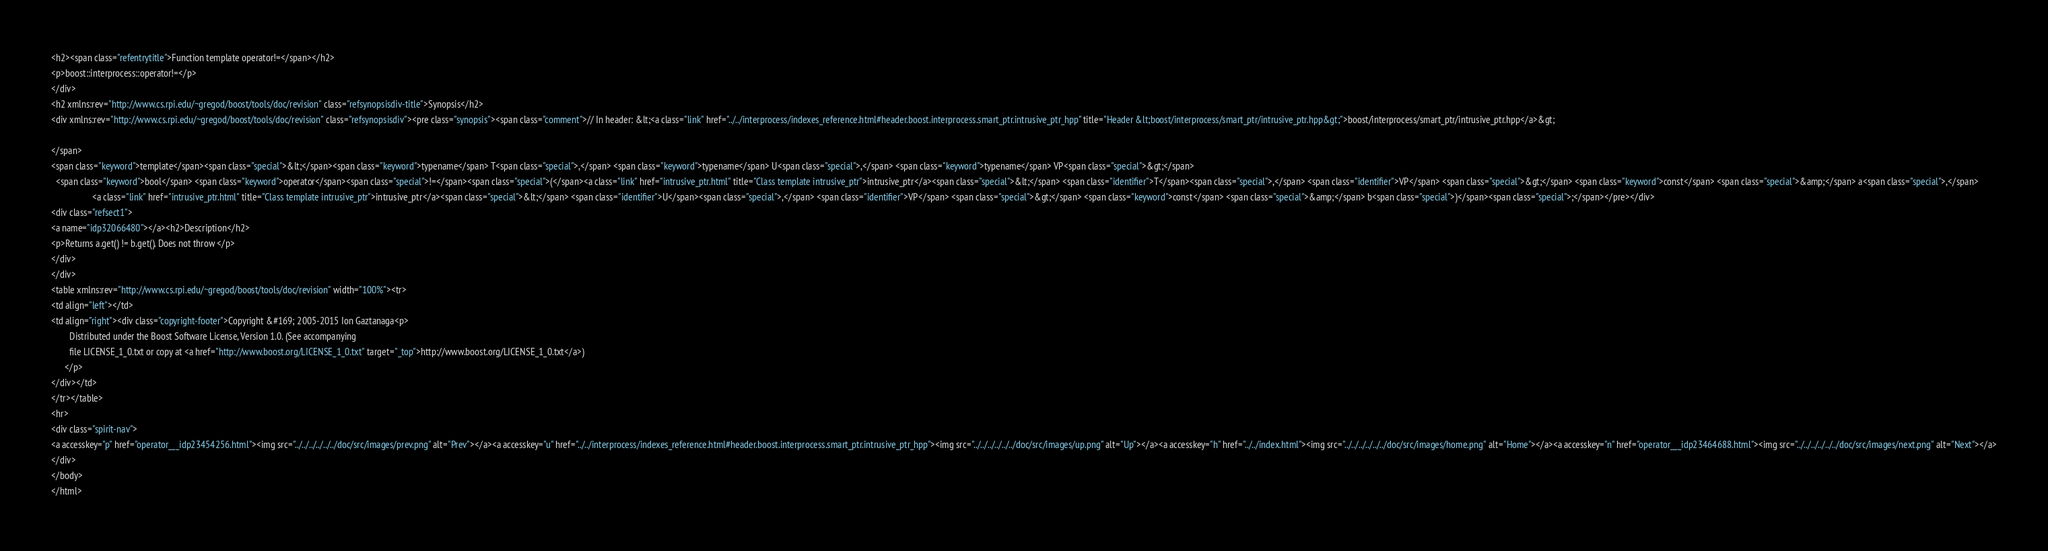Convert code to text. <code><loc_0><loc_0><loc_500><loc_500><_HTML_><h2><span class="refentrytitle">Function template operator!=</span></h2>
<p>boost::interprocess::operator!=</p>
</div>
<h2 xmlns:rev="http://www.cs.rpi.edu/~gregod/boost/tools/doc/revision" class="refsynopsisdiv-title">Synopsis</h2>
<div xmlns:rev="http://www.cs.rpi.edu/~gregod/boost/tools/doc/revision" class="refsynopsisdiv"><pre class="synopsis"><span class="comment">// In header: &lt;<a class="link" href="../../interprocess/indexes_reference.html#header.boost.interprocess.smart_ptr.intrusive_ptr_hpp" title="Header &lt;boost/interprocess/smart_ptr/intrusive_ptr.hpp&gt;">boost/interprocess/smart_ptr/intrusive_ptr.hpp</a>&gt;

</span>
<span class="keyword">template</span><span class="special">&lt;</span><span class="keyword">typename</span> T<span class="special">,</span> <span class="keyword">typename</span> U<span class="special">,</span> <span class="keyword">typename</span> VP<span class="special">&gt;</span> 
  <span class="keyword">bool</span> <span class="keyword">operator</span><span class="special">!=</span><span class="special">(</span><a class="link" href="intrusive_ptr.html" title="Class template intrusive_ptr">intrusive_ptr</a><span class="special">&lt;</span> <span class="identifier">T</span><span class="special">,</span> <span class="identifier">VP</span> <span class="special">&gt;</span> <span class="keyword">const</span> <span class="special">&amp;</span> a<span class="special">,</span> 
                  <a class="link" href="intrusive_ptr.html" title="Class template intrusive_ptr">intrusive_ptr</a><span class="special">&lt;</span> <span class="identifier">U</span><span class="special">,</span> <span class="identifier">VP</span> <span class="special">&gt;</span> <span class="keyword">const</span> <span class="special">&amp;</span> b<span class="special">)</span><span class="special">;</span></pre></div>
<div class="refsect1">
<a name="idp32066480"></a><h2>Description</h2>
<p>Returns a.get() != b.get(). Does not throw </p>
</div>
</div>
<table xmlns:rev="http://www.cs.rpi.edu/~gregod/boost/tools/doc/revision" width="100%"><tr>
<td align="left"></td>
<td align="right"><div class="copyright-footer">Copyright &#169; 2005-2015 Ion Gaztanaga<p>
        Distributed under the Boost Software License, Version 1.0. (See accompanying
        file LICENSE_1_0.txt or copy at <a href="http://www.boost.org/LICENSE_1_0.txt" target="_top">http://www.boost.org/LICENSE_1_0.txt</a>)
      </p>
</div></td>
</tr></table>
<hr>
<div class="spirit-nav">
<a accesskey="p" href="operator___idp23454256.html"><img src="../../../../../../doc/src/images/prev.png" alt="Prev"></a><a accesskey="u" href="../../interprocess/indexes_reference.html#header.boost.interprocess.smart_ptr.intrusive_ptr_hpp"><img src="../../../../../../doc/src/images/up.png" alt="Up"></a><a accesskey="h" href="../../index.html"><img src="../../../../../../doc/src/images/home.png" alt="Home"></a><a accesskey="n" href="operator___idp23464688.html"><img src="../../../../../../doc/src/images/next.png" alt="Next"></a>
</div>
</body>
</html>
</code> 